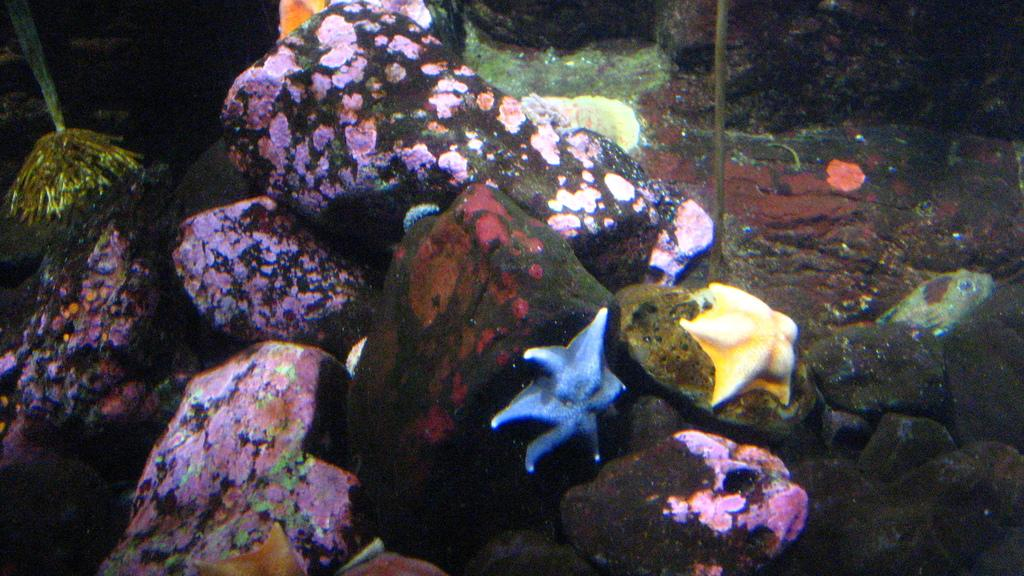What type of objects can be seen in the image? There are stones, a starfish, and a fish in the image. Where are these objects located? The objects are in the water. What type of loaf can be seen floating in the water in the image? There is no loaf present in the image; it features stones, a starfish, and a fish in the water. How does the parcel adjust its position in the water in the image? There is no parcel present in the image, so it cannot be determined how it would adjust its position in the water. 